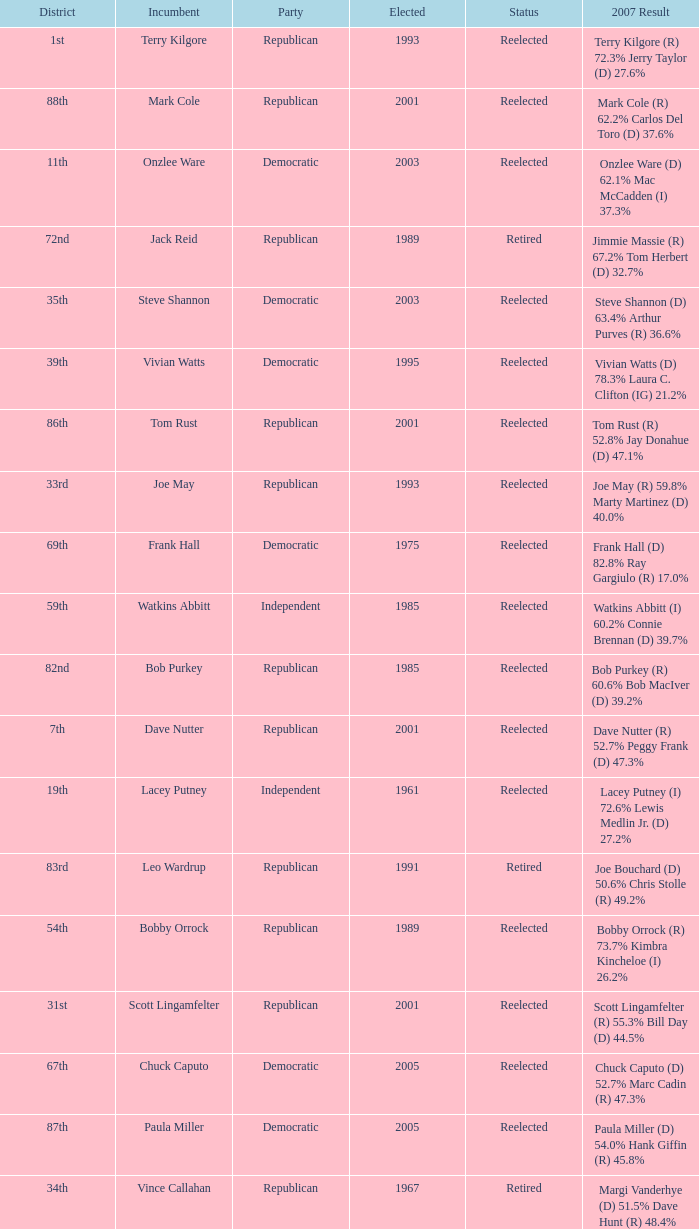What was the last year someone was elected to the 14th district? 2001.0. 